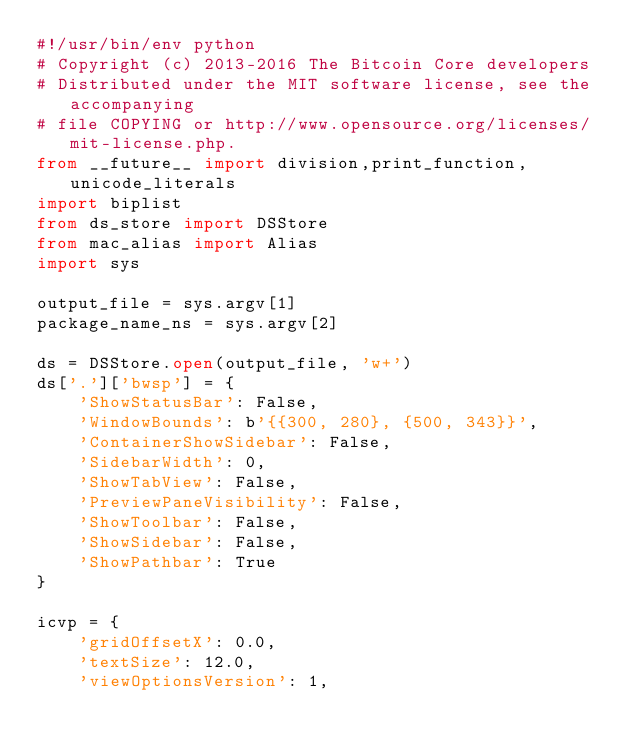<code> <loc_0><loc_0><loc_500><loc_500><_Python_>#!/usr/bin/env python
# Copyright (c) 2013-2016 The Bitcoin Core developers
# Distributed under the MIT software license, see the accompanying
# file COPYING or http://www.opensource.org/licenses/mit-license.php.
from __future__ import division,print_function,unicode_literals
import biplist
from ds_store import DSStore
from mac_alias import Alias
import sys

output_file = sys.argv[1]
package_name_ns = sys.argv[2]

ds = DSStore.open(output_file, 'w+')
ds['.']['bwsp'] = {
    'ShowStatusBar': False,
    'WindowBounds': b'{{300, 280}, {500, 343}}',
    'ContainerShowSidebar': False,
    'SidebarWidth': 0,
    'ShowTabView': False,
    'PreviewPaneVisibility': False,
    'ShowToolbar': False,
    'ShowSidebar': False,
    'ShowPathbar': True
}

icvp = {
    'gridOffsetX': 0.0,
    'textSize': 12.0,
    'viewOptionsVersion': 1,</code> 